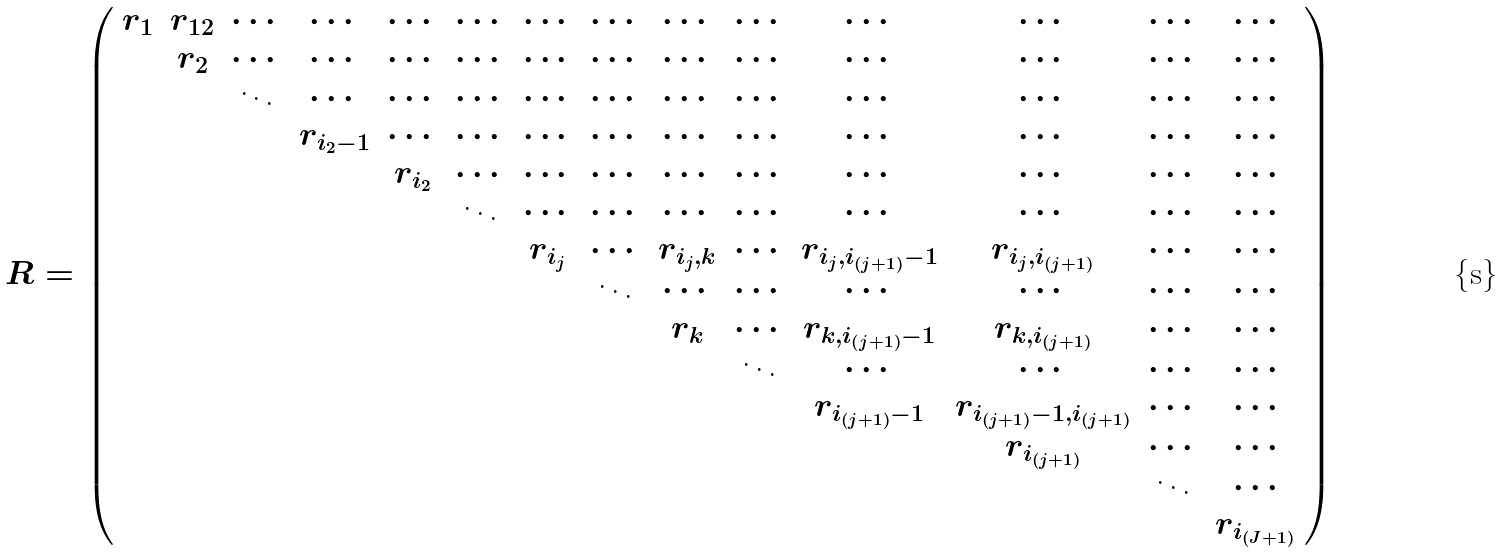Convert formula to latex. <formula><loc_0><loc_0><loc_500><loc_500>R = \left ( \begin{array} { c c c c c c c c c c c c c c } r _ { 1 } & r _ { 1 2 } & \cdots & \cdots & \cdots & \cdots & \cdots & \cdots & \cdots & \cdots & \cdots & \cdots & \cdots & \cdots \\ & r _ { 2 } & \cdots & \cdots & \cdots & \cdots & \cdots & \cdots & \cdots & \cdots & \cdots & \cdots & \cdots & \cdots \\ & & \ddots & \cdots & \cdots & \cdots & \cdots & \cdots & \cdots & \cdots & \cdots & \cdots & \cdots & \cdots \\ & & & r _ { i _ { 2 } - 1 } & \cdots & \cdots & \cdots & \cdots & \cdots & \cdots & \cdots & \cdots & \cdots & \cdots \\ & & & & r _ { i _ { 2 } } & \cdots & \cdots & \cdots & \cdots & \cdots & \cdots & \cdots & \cdots & \cdots \\ & & & & & \ddots & \cdots & \cdots & \cdots & \cdots & \cdots & \cdots & \cdots & \cdots \\ & & & & & & r _ { i _ { j } } & \cdots & r _ { i _ { j } , k } & \cdots & r _ { i _ { j } , i _ { ( j + 1 ) } - 1 } & r _ { i _ { j } , i _ { ( j + 1 ) } } & \cdots & \cdots \\ & & & & & & & \ddots & \cdots & \cdots & \cdots & \cdots & \cdots & \cdots \\ & & & & & & & & r _ { k } & \cdots & r _ { k , i _ { ( j + 1 ) } - 1 } & r _ { k , i _ { ( j + 1 ) } } & \cdots & \cdots \\ & & & & & & & & & \ddots & \cdots & \cdots & \cdots & \cdots \\ & & & & & & & & & & r _ { i _ { ( j + 1 ) } - 1 } & r _ { i _ { ( j + 1 ) } - 1 , i _ { ( j + 1 ) } } & \cdots & \cdots \\ & & & & & & & & & & & r _ { i _ { ( j + 1 ) } } & \cdots & \cdots \\ & & & & & & & & & & & & \ddots & \cdots \\ & & & & & & & & & & & & & r _ { i _ { ( J + 1 ) } } \end{array} \right )</formula> 